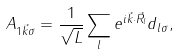<formula> <loc_0><loc_0><loc_500><loc_500>A _ { 1 \vec { k } \sigma } = \frac { 1 } { \sqrt { L } } \sum _ { l } e ^ { i \vec { k } \cdot \vec { R } _ { l } } d _ { l \sigma } ,</formula> 